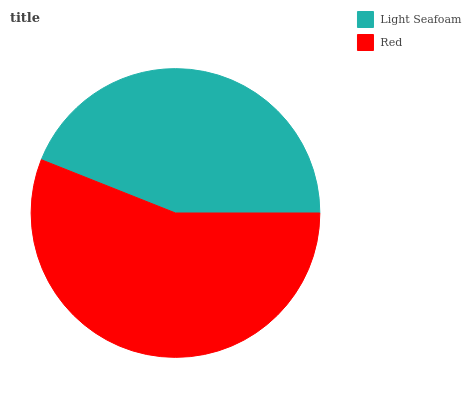Is Light Seafoam the minimum?
Answer yes or no. Yes. Is Red the maximum?
Answer yes or no. Yes. Is Red the minimum?
Answer yes or no. No. Is Red greater than Light Seafoam?
Answer yes or no. Yes. Is Light Seafoam less than Red?
Answer yes or no. Yes. Is Light Seafoam greater than Red?
Answer yes or no. No. Is Red less than Light Seafoam?
Answer yes or no. No. Is Red the high median?
Answer yes or no. Yes. Is Light Seafoam the low median?
Answer yes or no. Yes. Is Light Seafoam the high median?
Answer yes or no. No. Is Red the low median?
Answer yes or no. No. 